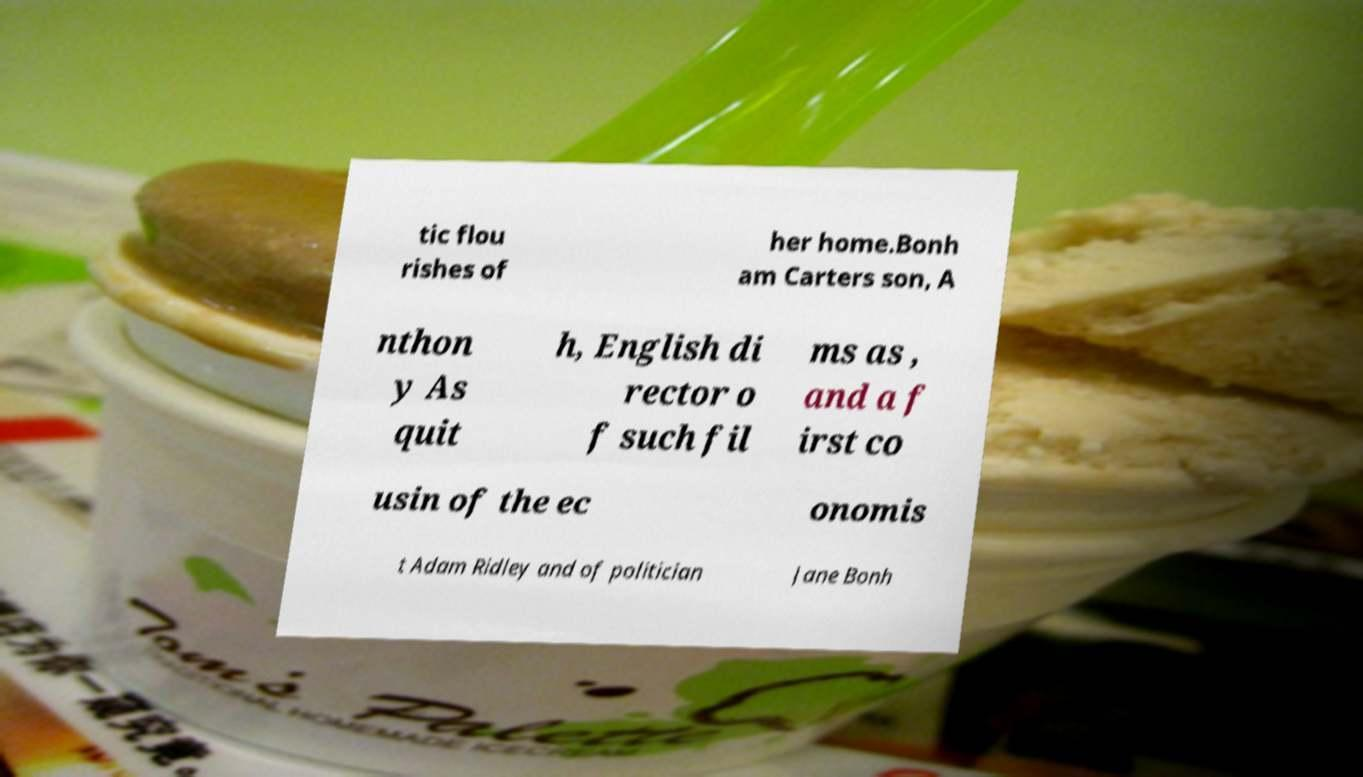Please identify and transcribe the text found in this image. tic flou rishes of her home.Bonh am Carters son, A nthon y As quit h, English di rector o f such fil ms as , and a f irst co usin of the ec onomis t Adam Ridley and of politician Jane Bonh 